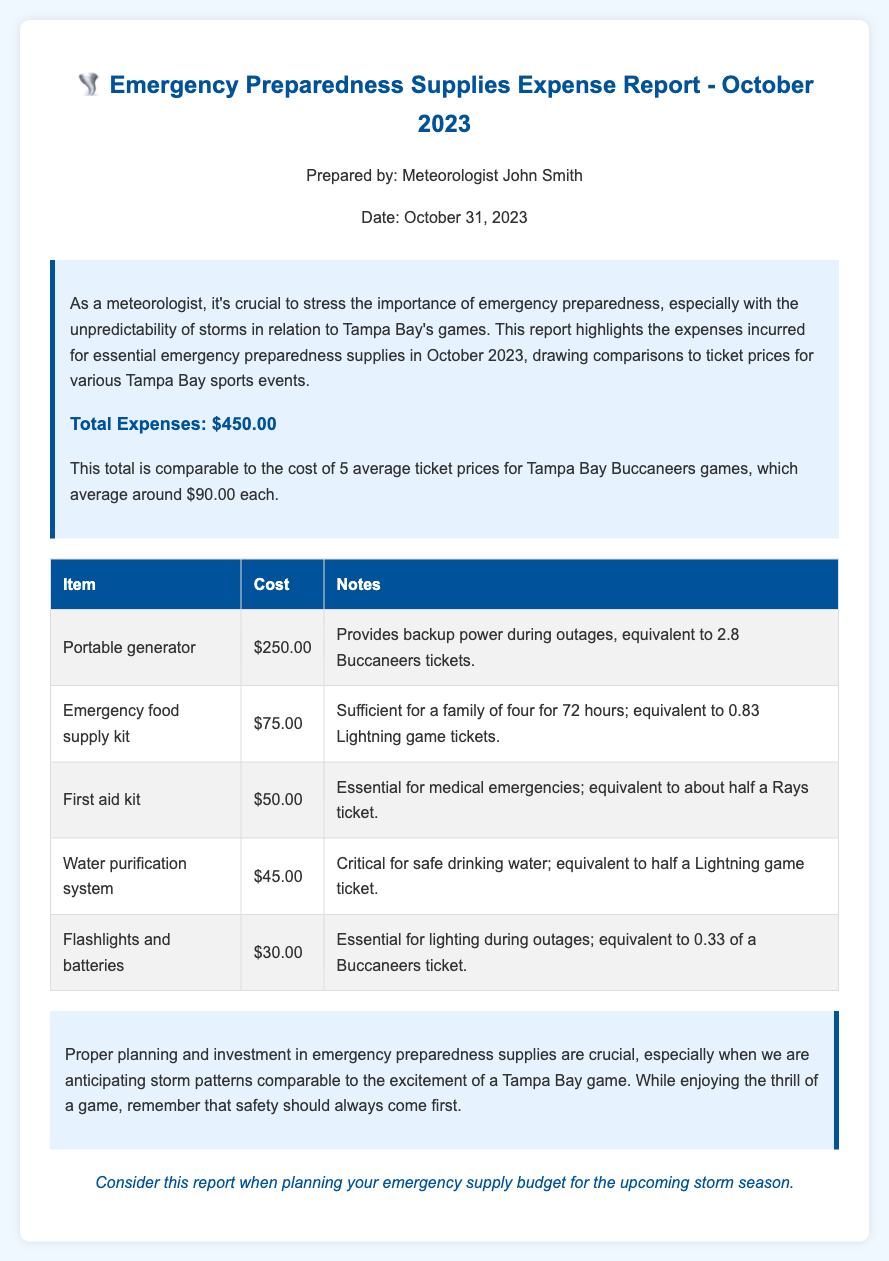what is the total expense reported? The total expense is clearly stated in the overview section of the document as $450.00.
Answer: $450.00 how many average Buccaneers tickets does the total expense equal? The document states that the total expense is equivalent to 5 average ticket prices for Buccaneers games.
Answer: 5 what was the cost of the portable generator? The cost of the portable generator is detailed in the table as $250.00.
Answer: $250.00 which item corresponds to a cost equivalent to 0.83 Lightning game tickets? The emergency food supply kit costs $75.00 and is noted to be equivalent to 0.83 Lightning game tickets.
Answer: Emergency food supply kit how critical is the water purification system? The document emphasizes that the water purification system is critical for safe drinking water.
Answer: critical how many total items are listed in the expense table? There are five items listed in the expense table.
Answer: 5 what is the equivalent ticket price for the flashlight and batteries? The cost for flashlights and batteries is equivalent to 0.33 of a Buccaneers ticket.
Answer: 0.33 of a Buccaneers ticket who prepared the report? The report is prepared by Meteorologist John Smith, as mentioned in the header of the document.
Answer: John Smith 